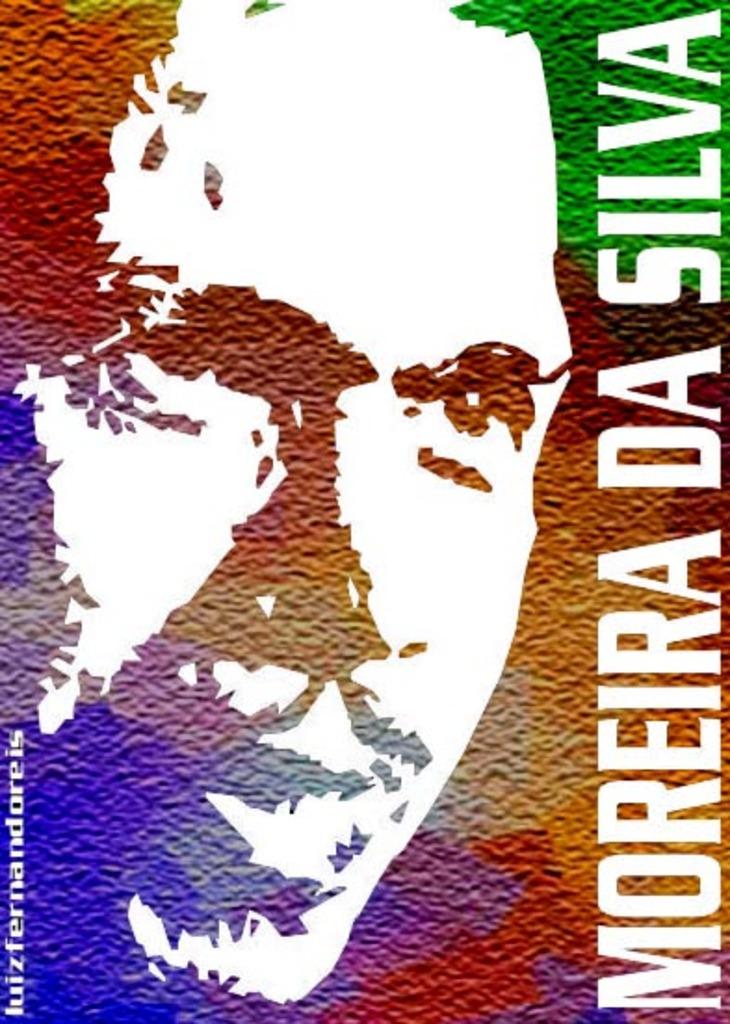What does the poster say?
Your answer should be very brief. Moreira da silva. How many soccer players are pictured?
Offer a terse response. Answering does not require reading text in the image. 